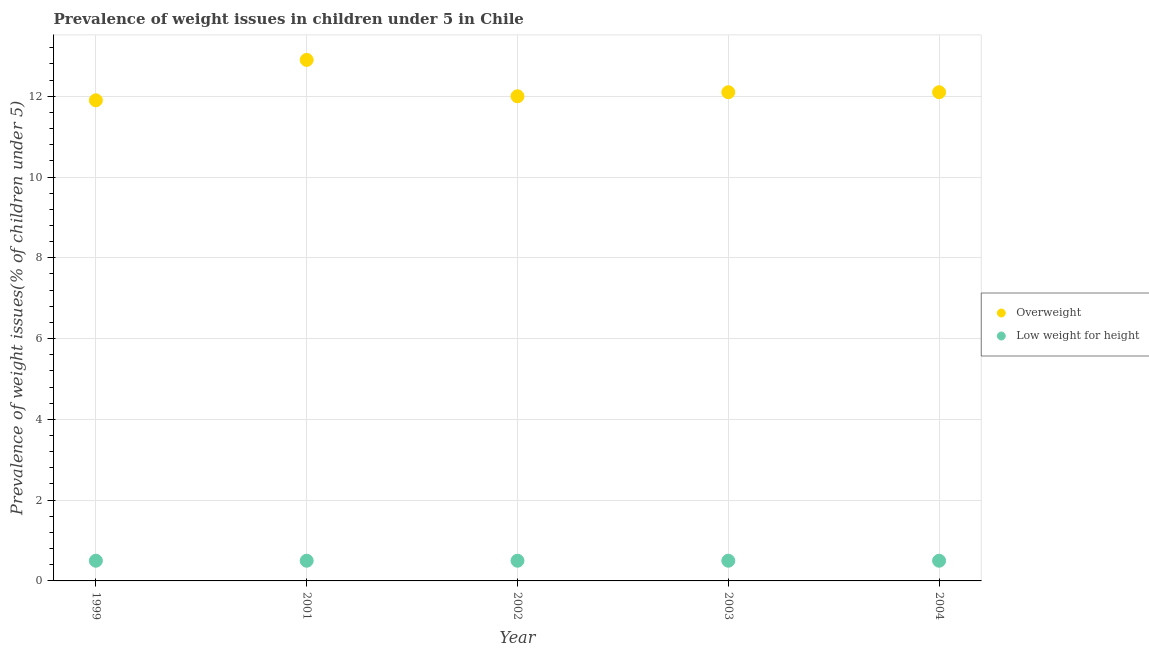How many different coloured dotlines are there?
Give a very brief answer. 2. Is the number of dotlines equal to the number of legend labels?
Your answer should be very brief. Yes. What is the percentage of overweight children in 2002?
Offer a terse response. 12. Across all years, what is the maximum percentage of overweight children?
Your response must be concise. 12.9. Across all years, what is the minimum percentage of overweight children?
Provide a short and direct response. 11.9. In which year was the percentage of underweight children maximum?
Make the answer very short. 1999. What is the difference between the percentage of overweight children in 2003 and the percentage of underweight children in 2002?
Make the answer very short. 11.6. In the year 2001, what is the difference between the percentage of underweight children and percentage of overweight children?
Give a very brief answer. -12.4. What is the ratio of the percentage of overweight children in 2001 to that in 2004?
Your answer should be compact. 1.07. What is the difference between the highest and the second highest percentage of overweight children?
Ensure brevity in your answer.  0.8. What is the difference between the highest and the lowest percentage of underweight children?
Make the answer very short. 0. In how many years, is the percentage of underweight children greater than the average percentage of underweight children taken over all years?
Offer a very short reply. 0. How many dotlines are there?
Make the answer very short. 2. How many years are there in the graph?
Provide a succinct answer. 5. How are the legend labels stacked?
Provide a succinct answer. Vertical. What is the title of the graph?
Provide a short and direct response. Prevalence of weight issues in children under 5 in Chile. Does "Non-resident workers" appear as one of the legend labels in the graph?
Offer a very short reply. No. What is the label or title of the Y-axis?
Provide a succinct answer. Prevalence of weight issues(% of children under 5). What is the Prevalence of weight issues(% of children under 5) of Overweight in 1999?
Your response must be concise. 11.9. What is the Prevalence of weight issues(% of children under 5) of Low weight for height in 1999?
Your answer should be very brief. 0.5. What is the Prevalence of weight issues(% of children under 5) in Overweight in 2001?
Keep it short and to the point. 12.9. What is the Prevalence of weight issues(% of children under 5) of Overweight in 2002?
Ensure brevity in your answer.  12. What is the Prevalence of weight issues(% of children under 5) of Low weight for height in 2002?
Give a very brief answer. 0.5. What is the Prevalence of weight issues(% of children under 5) in Overweight in 2003?
Give a very brief answer. 12.1. What is the Prevalence of weight issues(% of children under 5) in Overweight in 2004?
Provide a short and direct response. 12.1. What is the Prevalence of weight issues(% of children under 5) in Low weight for height in 2004?
Keep it short and to the point. 0.5. Across all years, what is the maximum Prevalence of weight issues(% of children under 5) in Overweight?
Ensure brevity in your answer.  12.9. Across all years, what is the maximum Prevalence of weight issues(% of children under 5) in Low weight for height?
Offer a terse response. 0.5. Across all years, what is the minimum Prevalence of weight issues(% of children under 5) in Overweight?
Give a very brief answer. 11.9. What is the difference between the Prevalence of weight issues(% of children under 5) of Low weight for height in 1999 and that in 2001?
Make the answer very short. 0. What is the difference between the Prevalence of weight issues(% of children under 5) of Overweight in 1999 and that in 2002?
Provide a succinct answer. -0.1. What is the difference between the Prevalence of weight issues(% of children under 5) in Low weight for height in 1999 and that in 2002?
Offer a terse response. 0. What is the difference between the Prevalence of weight issues(% of children under 5) in Low weight for height in 1999 and that in 2003?
Make the answer very short. 0. What is the difference between the Prevalence of weight issues(% of children under 5) of Overweight in 1999 and that in 2004?
Give a very brief answer. -0.2. What is the difference between the Prevalence of weight issues(% of children under 5) in Low weight for height in 1999 and that in 2004?
Make the answer very short. 0. What is the difference between the Prevalence of weight issues(% of children under 5) of Overweight in 2001 and that in 2002?
Make the answer very short. 0.9. What is the difference between the Prevalence of weight issues(% of children under 5) in Low weight for height in 2001 and that in 2002?
Your answer should be compact. 0. What is the difference between the Prevalence of weight issues(% of children under 5) in Overweight in 2001 and that in 2003?
Offer a terse response. 0.8. What is the difference between the Prevalence of weight issues(% of children under 5) of Low weight for height in 2001 and that in 2003?
Your answer should be very brief. 0. What is the difference between the Prevalence of weight issues(% of children under 5) in Low weight for height in 2001 and that in 2004?
Ensure brevity in your answer.  0. What is the difference between the Prevalence of weight issues(% of children under 5) in Low weight for height in 2002 and that in 2003?
Make the answer very short. 0. What is the difference between the Prevalence of weight issues(% of children under 5) in Low weight for height in 2002 and that in 2004?
Your response must be concise. 0. What is the difference between the Prevalence of weight issues(% of children under 5) in Low weight for height in 2003 and that in 2004?
Keep it short and to the point. 0. What is the difference between the Prevalence of weight issues(% of children under 5) of Overweight in 1999 and the Prevalence of weight issues(% of children under 5) of Low weight for height in 2002?
Offer a terse response. 11.4. What is the difference between the Prevalence of weight issues(% of children under 5) in Overweight in 1999 and the Prevalence of weight issues(% of children under 5) in Low weight for height in 2003?
Your answer should be very brief. 11.4. What is the difference between the Prevalence of weight issues(% of children under 5) in Overweight in 2001 and the Prevalence of weight issues(% of children under 5) in Low weight for height in 2003?
Offer a very short reply. 12.4. What is the difference between the Prevalence of weight issues(% of children under 5) in Overweight in 2002 and the Prevalence of weight issues(% of children under 5) in Low weight for height in 2004?
Offer a very short reply. 11.5. In the year 2002, what is the difference between the Prevalence of weight issues(% of children under 5) of Overweight and Prevalence of weight issues(% of children under 5) of Low weight for height?
Keep it short and to the point. 11.5. What is the ratio of the Prevalence of weight issues(% of children under 5) of Overweight in 1999 to that in 2001?
Offer a terse response. 0.92. What is the ratio of the Prevalence of weight issues(% of children under 5) in Low weight for height in 1999 to that in 2002?
Give a very brief answer. 1. What is the ratio of the Prevalence of weight issues(% of children under 5) in Overweight in 1999 to that in 2003?
Your answer should be compact. 0.98. What is the ratio of the Prevalence of weight issues(% of children under 5) in Overweight in 1999 to that in 2004?
Keep it short and to the point. 0.98. What is the ratio of the Prevalence of weight issues(% of children under 5) in Low weight for height in 1999 to that in 2004?
Offer a very short reply. 1. What is the ratio of the Prevalence of weight issues(% of children under 5) in Overweight in 2001 to that in 2002?
Make the answer very short. 1.07. What is the ratio of the Prevalence of weight issues(% of children under 5) of Low weight for height in 2001 to that in 2002?
Your response must be concise. 1. What is the ratio of the Prevalence of weight issues(% of children under 5) of Overweight in 2001 to that in 2003?
Give a very brief answer. 1.07. What is the ratio of the Prevalence of weight issues(% of children under 5) of Low weight for height in 2001 to that in 2003?
Keep it short and to the point. 1. What is the ratio of the Prevalence of weight issues(% of children under 5) in Overweight in 2001 to that in 2004?
Your answer should be very brief. 1.07. What is the ratio of the Prevalence of weight issues(% of children under 5) in Low weight for height in 2001 to that in 2004?
Offer a terse response. 1. What is the ratio of the Prevalence of weight issues(% of children under 5) in Overweight in 2002 to that in 2004?
Your answer should be very brief. 0.99. What is the ratio of the Prevalence of weight issues(% of children under 5) of Overweight in 2003 to that in 2004?
Offer a terse response. 1. What is the ratio of the Prevalence of weight issues(% of children under 5) in Low weight for height in 2003 to that in 2004?
Give a very brief answer. 1. What is the difference between the highest and the second highest Prevalence of weight issues(% of children under 5) in Overweight?
Ensure brevity in your answer.  0.8. What is the difference between the highest and the second highest Prevalence of weight issues(% of children under 5) of Low weight for height?
Your answer should be compact. 0. What is the difference between the highest and the lowest Prevalence of weight issues(% of children under 5) of Overweight?
Your answer should be compact. 1. 